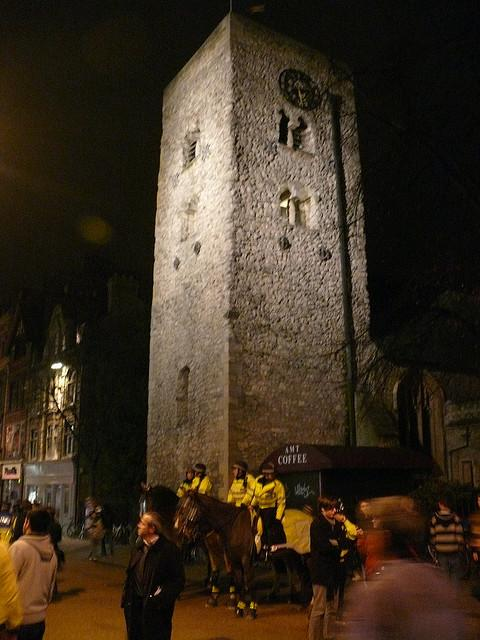What material is the construction of this tower? stone 